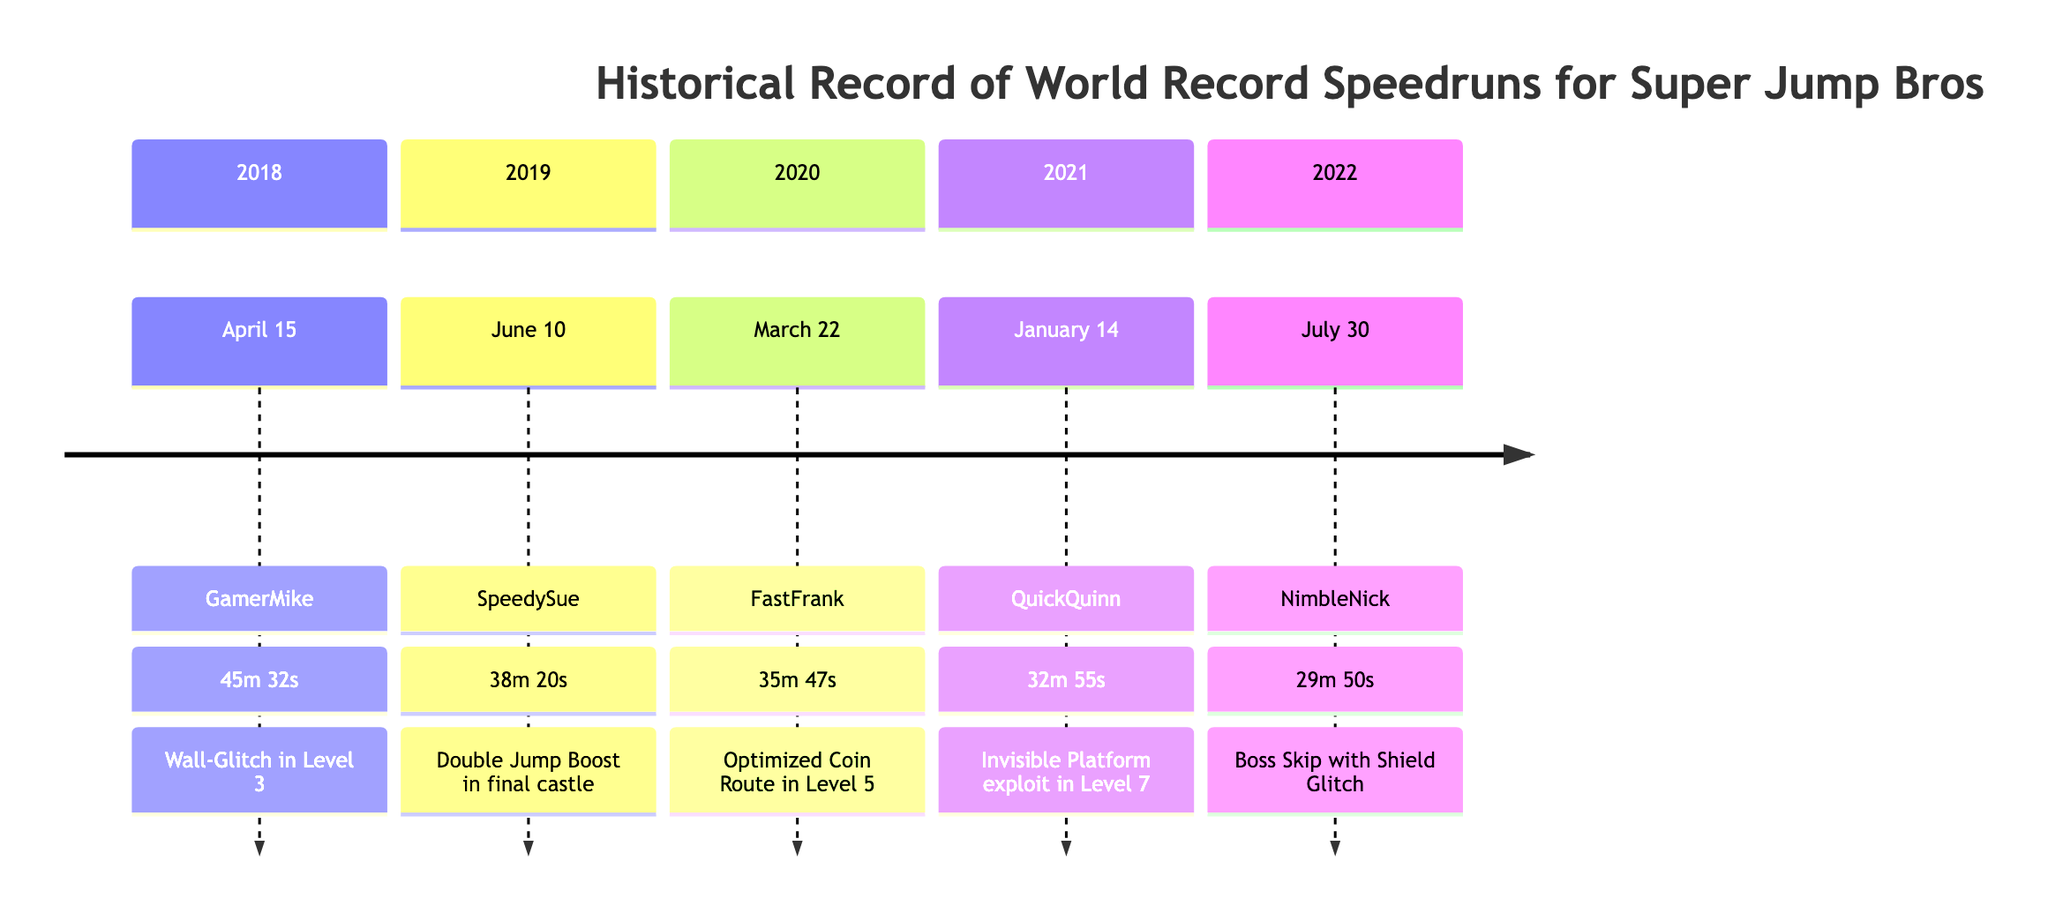What is the record time set by NimbleNick? According to the timeline, NimbleNick set the record time of 29m 50s on July 30, 2022. Therefore, this is the answer.
Answer: 29m 50s Who held the record before QuickQuinn? The record holder before QuickQuinn, who set a record on January 14, 2021, was FastFrank, who achieved a record time on March 22, 2020. Therefore, FastFrank is the answer.
Answer: FastFrank What key strategy was introduced by SpeedySue? SpeedySue introduced the 'Double Jump Boost' technique in the final castle, which is specifically mentioned in her record entry.
Answer: Double Jump Boost How many total record holders are listed in the timeline? The timeline provides records for five different record holders, each with a distinct entry detailing their achievement. Thus, the total count is five.
Answer: 5 What was the key strategy change that led to the fastest time? The key strategy that contributed to the fastest recorded time of 29m 50s by NimbleNick was the perfect execution of 'Boss Skip' using the 'Shield Glitch.' This indicates it provided a significant advantage.
Answer: Boss Skip with Shield Glitch Which year saw the first recorded world record? The first world record was set by GamerMike on April 15, 2018, which is the earliest date listed in the timeline. Thus, the answer is 2018.
Answer: 2018 What date did FastFrank set his record? FastFrank set his record on March 22, 2020, as outlined in the timeline. This is the specific date for his achievement.
Answer: March 22, 2020 What is the difference in record times between SpeedySue and NimbleNick? SpeedySue recorded a time of 38m 20s and NimbleNick recorded a time of 29m 50s. To find the difference, we convert both times into seconds, calculate the difference (38*60 + 20) - (29*60 + 50) = 1,830 seconds - 1,790 seconds = 40 seconds. This shows the time difference between their records.
Answer: 40 seconds 